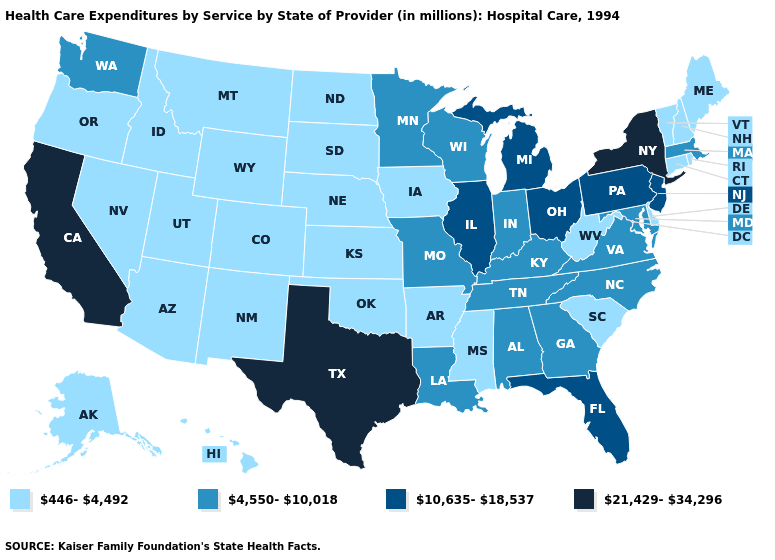Does the map have missing data?
Keep it brief. No. Which states have the highest value in the USA?
Short answer required. California, New York, Texas. How many symbols are there in the legend?
Be succinct. 4. Among the states that border Georgia , which have the highest value?
Quick response, please. Florida. Name the states that have a value in the range 446-4,492?
Answer briefly. Alaska, Arizona, Arkansas, Colorado, Connecticut, Delaware, Hawaii, Idaho, Iowa, Kansas, Maine, Mississippi, Montana, Nebraska, Nevada, New Hampshire, New Mexico, North Dakota, Oklahoma, Oregon, Rhode Island, South Carolina, South Dakota, Utah, Vermont, West Virginia, Wyoming. Name the states that have a value in the range 21,429-34,296?
Be succinct. California, New York, Texas. Is the legend a continuous bar?
Write a very short answer. No. What is the highest value in the USA?
Quick response, please. 21,429-34,296. What is the value of West Virginia?
Be succinct. 446-4,492. Among the states that border Missouri , which have the highest value?
Be succinct. Illinois. Does Florida have a higher value than Oregon?
Concise answer only. Yes. What is the highest value in states that border Oklahoma?
Give a very brief answer. 21,429-34,296. Does Connecticut have the highest value in the USA?
Write a very short answer. No. Name the states that have a value in the range 4,550-10,018?
Quick response, please. Alabama, Georgia, Indiana, Kentucky, Louisiana, Maryland, Massachusetts, Minnesota, Missouri, North Carolina, Tennessee, Virginia, Washington, Wisconsin. 